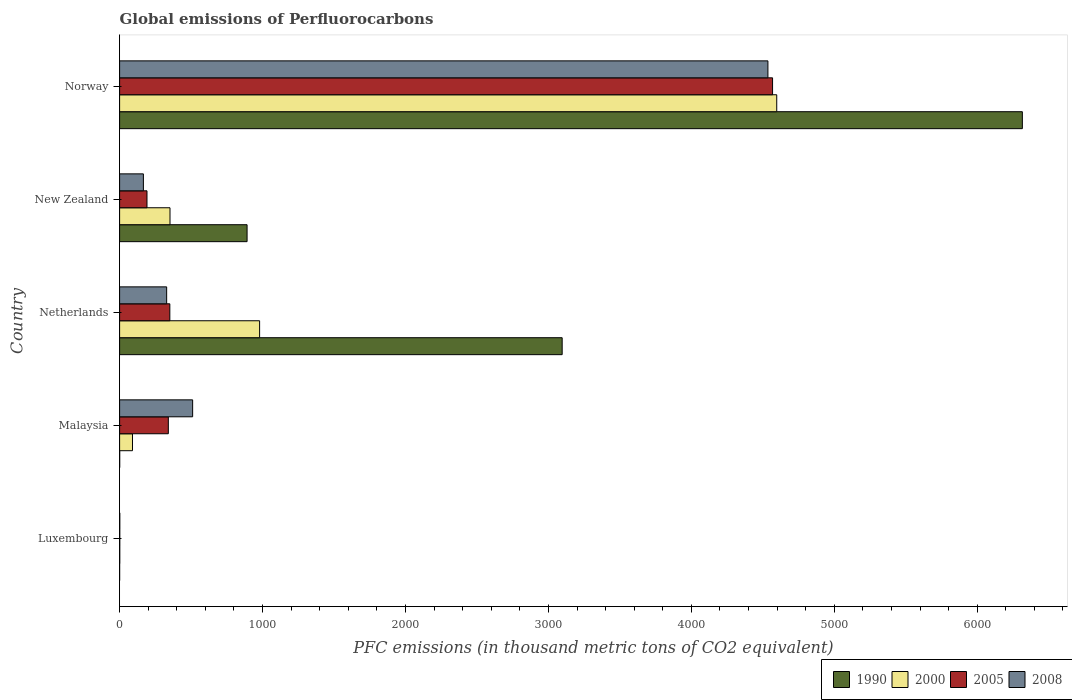Are the number of bars per tick equal to the number of legend labels?
Make the answer very short. Yes. Are the number of bars on each tick of the Y-axis equal?
Your answer should be very brief. Yes. How many bars are there on the 4th tick from the top?
Offer a very short reply. 4. What is the label of the 4th group of bars from the top?
Your answer should be compact. Malaysia. In how many cases, is the number of bars for a given country not equal to the number of legend labels?
Keep it short and to the point. 0. What is the global emissions of Perfluorocarbons in 1990 in Netherlands?
Provide a short and direct response. 3096.2. Across all countries, what is the maximum global emissions of Perfluorocarbons in 2008?
Offer a very short reply. 4535.7. Across all countries, what is the minimum global emissions of Perfluorocarbons in 2005?
Give a very brief answer. 1.1. In which country was the global emissions of Perfluorocarbons in 2008 maximum?
Offer a terse response. Norway. In which country was the global emissions of Perfluorocarbons in 1990 minimum?
Provide a succinct answer. Luxembourg. What is the total global emissions of Perfluorocarbons in 2008 in the graph?
Give a very brief answer. 5543.5. What is the difference between the global emissions of Perfluorocarbons in 2005 in New Zealand and that in Norway?
Keep it short and to the point. -4376.5. What is the difference between the global emissions of Perfluorocarbons in 1990 in Netherlands and the global emissions of Perfluorocarbons in 2008 in New Zealand?
Your answer should be compact. 2929.8. What is the average global emissions of Perfluorocarbons in 2000 per country?
Provide a short and direct response. 1204.1. What is the difference between the global emissions of Perfluorocarbons in 2008 and global emissions of Perfluorocarbons in 1990 in New Zealand?
Your answer should be very brief. -725.4. What is the ratio of the global emissions of Perfluorocarbons in 2008 in Luxembourg to that in Norway?
Provide a succinct answer. 0. Is the global emissions of Perfluorocarbons in 2005 in Luxembourg less than that in Norway?
Your response must be concise. Yes. Is the difference between the global emissions of Perfluorocarbons in 2008 in Malaysia and New Zealand greater than the difference between the global emissions of Perfluorocarbons in 1990 in Malaysia and New Zealand?
Your answer should be compact. Yes. What is the difference between the highest and the second highest global emissions of Perfluorocarbons in 2008?
Your answer should be compact. 4024.7. What is the difference between the highest and the lowest global emissions of Perfluorocarbons in 2008?
Give a very brief answer. 4534.5. Is the sum of the global emissions of Perfluorocarbons in 2000 in New Zealand and Norway greater than the maximum global emissions of Perfluorocarbons in 2008 across all countries?
Your response must be concise. Yes. Is it the case that in every country, the sum of the global emissions of Perfluorocarbons in 2005 and global emissions of Perfluorocarbons in 2008 is greater than the sum of global emissions of Perfluorocarbons in 1990 and global emissions of Perfluorocarbons in 2000?
Your response must be concise. No. What does the 4th bar from the top in Luxembourg represents?
Provide a succinct answer. 1990. What does the 3rd bar from the bottom in Malaysia represents?
Provide a succinct answer. 2005. Is it the case that in every country, the sum of the global emissions of Perfluorocarbons in 1990 and global emissions of Perfluorocarbons in 2005 is greater than the global emissions of Perfluorocarbons in 2000?
Give a very brief answer. Yes. Are all the bars in the graph horizontal?
Your response must be concise. Yes. What is the difference between two consecutive major ticks on the X-axis?
Offer a very short reply. 1000. Does the graph contain any zero values?
Keep it short and to the point. No. Where does the legend appear in the graph?
Provide a short and direct response. Bottom right. How many legend labels are there?
Keep it short and to the point. 4. How are the legend labels stacked?
Keep it short and to the point. Horizontal. What is the title of the graph?
Provide a short and direct response. Global emissions of Perfluorocarbons. What is the label or title of the X-axis?
Give a very brief answer. PFC emissions (in thousand metric tons of CO2 equivalent). What is the PFC emissions (in thousand metric tons of CO2 equivalent) in 1990 in Luxembourg?
Offer a terse response. 0.1. What is the PFC emissions (in thousand metric tons of CO2 equivalent) of 2000 in Luxembourg?
Your answer should be compact. 1. What is the PFC emissions (in thousand metric tons of CO2 equivalent) of 2005 in Luxembourg?
Ensure brevity in your answer.  1.1. What is the PFC emissions (in thousand metric tons of CO2 equivalent) in 2008 in Luxembourg?
Offer a terse response. 1.2. What is the PFC emissions (in thousand metric tons of CO2 equivalent) of 1990 in Malaysia?
Give a very brief answer. 0.6. What is the PFC emissions (in thousand metric tons of CO2 equivalent) of 2000 in Malaysia?
Your answer should be very brief. 90.1. What is the PFC emissions (in thousand metric tons of CO2 equivalent) of 2005 in Malaysia?
Your answer should be very brief. 340.9. What is the PFC emissions (in thousand metric tons of CO2 equivalent) in 2008 in Malaysia?
Make the answer very short. 511. What is the PFC emissions (in thousand metric tons of CO2 equivalent) in 1990 in Netherlands?
Provide a short and direct response. 3096.2. What is the PFC emissions (in thousand metric tons of CO2 equivalent) in 2000 in Netherlands?
Offer a terse response. 979.5. What is the PFC emissions (in thousand metric tons of CO2 equivalent) of 2005 in Netherlands?
Your answer should be compact. 351.4. What is the PFC emissions (in thousand metric tons of CO2 equivalent) of 2008 in Netherlands?
Your answer should be very brief. 329.2. What is the PFC emissions (in thousand metric tons of CO2 equivalent) of 1990 in New Zealand?
Keep it short and to the point. 891.8. What is the PFC emissions (in thousand metric tons of CO2 equivalent) in 2000 in New Zealand?
Make the answer very short. 352.6. What is the PFC emissions (in thousand metric tons of CO2 equivalent) in 2005 in New Zealand?
Your response must be concise. 191.6. What is the PFC emissions (in thousand metric tons of CO2 equivalent) of 2008 in New Zealand?
Ensure brevity in your answer.  166.4. What is the PFC emissions (in thousand metric tons of CO2 equivalent) in 1990 in Norway?
Keep it short and to the point. 6315.7. What is the PFC emissions (in thousand metric tons of CO2 equivalent) in 2000 in Norway?
Ensure brevity in your answer.  4597.3. What is the PFC emissions (in thousand metric tons of CO2 equivalent) of 2005 in Norway?
Make the answer very short. 4568.1. What is the PFC emissions (in thousand metric tons of CO2 equivalent) in 2008 in Norway?
Make the answer very short. 4535.7. Across all countries, what is the maximum PFC emissions (in thousand metric tons of CO2 equivalent) of 1990?
Offer a terse response. 6315.7. Across all countries, what is the maximum PFC emissions (in thousand metric tons of CO2 equivalent) in 2000?
Give a very brief answer. 4597.3. Across all countries, what is the maximum PFC emissions (in thousand metric tons of CO2 equivalent) of 2005?
Provide a short and direct response. 4568.1. Across all countries, what is the maximum PFC emissions (in thousand metric tons of CO2 equivalent) in 2008?
Provide a succinct answer. 4535.7. Across all countries, what is the minimum PFC emissions (in thousand metric tons of CO2 equivalent) of 2005?
Ensure brevity in your answer.  1.1. Across all countries, what is the minimum PFC emissions (in thousand metric tons of CO2 equivalent) in 2008?
Your answer should be very brief. 1.2. What is the total PFC emissions (in thousand metric tons of CO2 equivalent) of 1990 in the graph?
Offer a terse response. 1.03e+04. What is the total PFC emissions (in thousand metric tons of CO2 equivalent) of 2000 in the graph?
Your answer should be compact. 6020.5. What is the total PFC emissions (in thousand metric tons of CO2 equivalent) of 2005 in the graph?
Offer a very short reply. 5453.1. What is the total PFC emissions (in thousand metric tons of CO2 equivalent) of 2008 in the graph?
Offer a terse response. 5543.5. What is the difference between the PFC emissions (in thousand metric tons of CO2 equivalent) in 1990 in Luxembourg and that in Malaysia?
Your answer should be compact. -0.5. What is the difference between the PFC emissions (in thousand metric tons of CO2 equivalent) of 2000 in Luxembourg and that in Malaysia?
Provide a short and direct response. -89.1. What is the difference between the PFC emissions (in thousand metric tons of CO2 equivalent) of 2005 in Luxembourg and that in Malaysia?
Make the answer very short. -339.8. What is the difference between the PFC emissions (in thousand metric tons of CO2 equivalent) of 2008 in Luxembourg and that in Malaysia?
Offer a terse response. -509.8. What is the difference between the PFC emissions (in thousand metric tons of CO2 equivalent) of 1990 in Luxembourg and that in Netherlands?
Make the answer very short. -3096.1. What is the difference between the PFC emissions (in thousand metric tons of CO2 equivalent) of 2000 in Luxembourg and that in Netherlands?
Your answer should be compact. -978.5. What is the difference between the PFC emissions (in thousand metric tons of CO2 equivalent) in 2005 in Luxembourg and that in Netherlands?
Provide a short and direct response. -350.3. What is the difference between the PFC emissions (in thousand metric tons of CO2 equivalent) in 2008 in Luxembourg and that in Netherlands?
Ensure brevity in your answer.  -328. What is the difference between the PFC emissions (in thousand metric tons of CO2 equivalent) in 1990 in Luxembourg and that in New Zealand?
Your answer should be very brief. -891.7. What is the difference between the PFC emissions (in thousand metric tons of CO2 equivalent) of 2000 in Luxembourg and that in New Zealand?
Make the answer very short. -351.6. What is the difference between the PFC emissions (in thousand metric tons of CO2 equivalent) of 2005 in Luxembourg and that in New Zealand?
Your answer should be very brief. -190.5. What is the difference between the PFC emissions (in thousand metric tons of CO2 equivalent) in 2008 in Luxembourg and that in New Zealand?
Ensure brevity in your answer.  -165.2. What is the difference between the PFC emissions (in thousand metric tons of CO2 equivalent) of 1990 in Luxembourg and that in Norway?
Make the answer very short. -6315.6. What is the difference between the PFC emissions (in thousand metric tons of CO2 equivalent) in 2000 in Luxembourg and that in Norway?
Your response must be concise. -4596.3. What is the difference between the PFC emissions (in thousand metric tons of CO2 equivalent) of 2005 in Luxembourg and that in Norway?
Your answer should be very brief. -4567. What is the difference between the PFC emissions (in thousand metric tons of CO2 equivalent) in 2008 in Luxembourg and that in Norway?
Your answer should be very brief. -4534.5. What is the difference between the PFC emissions (in thousand metric tons of CO2 equivalent) in 1990 in Malaysia and that in Netherlands?
Your response must be concise. -3095.6. What is the difference between the PFC emissions (in thousand metric tons of CO2 equivalent) in 2000 in Malaysia and that in Netherlands?
Your answer should be very brief. -889.4. What is the difference between the PFC emissions (in thousand metric tons of CO2 equivalent) of 2008 in Malaysia and that in Netherlands?
Offer a very short reply. 181.8. What is the difference between the PFC emissions (in thousand metric tons of CO2 equivalent) of 1990 in Malaysia and that in New Zealand?
Make the answer very short. -891.2. What is the difference between the PFC emissions (in thousand metric tons of CO2 equivalent) in 2000 in Malaysia and that in New Zealand?
Make the answer very short. -262.5. What is the difference between the PFC emissions (in thousand metric tons of CO2 equivalent) of 2005 in Malaysia and that in New Zealand?
Your answer should be very brief. 149.3. What is the difference between the PFC emissions (in thousand metric tons of CO2 equivalent) in 2008 in Malaysia and that in New Zealand?
Offer a very short reply. 344.6. What is the difference between the PFC emissions (in thousand metric tons of CO2 equivalent) in 1990 in Malaysia and that in Norway?
Provide a short and direct response. -6315.1. What is the difference between the PFC emissions (in thousand metric tons of CO2 equivalent) in 2000 in Malaysia and that in Norway?
Provide a short and direct response. -4507.2. What is the difference between the PFC emissions (in thousand metric tons of CO2 equivalent) in 2005 in Malaysia and that in Norway?
Your answer should be very brief. -4227.2. What is the difference between the PFC emissions (in thousand metric tons of CO2 equivalent) of 2008 in Malaysia and that in Norway?
Keep it short and to the point. -4024.7. What is the difference between the PFC emissions (in thousand metric tons of CO2 equivalent) in 1990 in Netherlands and that in New Zealand?
Provide a short and direct response. 2204.4. What is the difference between the PFC emissions (in thousand metric tons of CO2 equivalent) of 2000 in Netherlands and that in New Zealand?
Ensure brevity in your answer.  626.9. What is the difference between the PFC emissions (in thousand metric tons of CO2 equivalent) in 2005 in Netherlands and that in New Zealand?
Make the answer very short. 159.8. What is the difference between the PFC emissions (in thousand metric tons of CO2 equivalent) in 2008 in Netherlands and that in New Zealand?
Provide a succinct answer. 162.8. What is the difference between the PFC emissions (in thousand metric tons of CO2 equivalent) of 1990 in Netherlands and that in Norway?
Provide a succinct answer. -3219.5. What is the difference between the PFC emissions (in thousand metric tons of CO2 equivalent) in 2000 in Netherlands and that in Norway?
Offer a very short reply. -3617.8. What is the difference between the PFC emissions (in thousand metric tons of CO2 equivalent) in 2005 in Netherlands and that in Norway?
Your answer should be very brief. -4216.7. What is the difference between the PFC emissions (in thousand metric tons of CO2 equivalent) of 2008 in Netherlands and that in Norway?
Make the answer very short. -4206.5. What is the difference between the PFC emissions (in thousand metric tons of CO2 equivalent) of 1990 in New Zealand and that in Norway?
Your answer should be very brief. -5423.9. What is the difference between the PFC emissions (in thousand metric tons of CO2 equivalent) of 2000 in New Zealand and that in Norway?
Your answer should be compact. -4244.7. What is the difference between the PFC emissions (in thousand metric tons of CO2 equivalent) of 2005 in New Zealand and that in Norway?
Provide a succinct answer. -4376.5. What is the difference between the PFC emissions (in thousand metric tons of CO2 equivalent) in 2008 in New Zealand and that in Norway?
Make the answer very short. -4369.3. What is the difference between the PFC emissions (in thousand metric tons of CO2 equivalent) of 1990 in Luxembourg and the PFC emissions (in thousand metric tons of CO2 equivalent) of 2000 in Malaysia?
Offer a very short reply. -90. What is the difference between the PFC emissions (in thousand metric tons of CO2 equivalent) of 1990 in Luxembourg and the PFC emissions (in thousand metric tons of CO2 equivalent) of 2005 in Malaysia?
Offer a very short reply. -340.8. What is the difference between the PFC emissions (in thousand metric tons of CO2 equivalent) of 1990 in Luxembourg and the PFC emissions (in thousand metric tons of CO2 equivalent) of 2008 in Malaysia?
Your answer should be compact. -510.9. What is the difference between the PFC emissions (in thousand metric tons of CO2 equivalent) of 2000 in Luxembourg and the PFC emissions (in thousand metric tons of CO2 equivalent) of 2005 in Malaysia?
Your response must be concise. -339.9. What is the difference between the PFC emissions (in thousand metric tons of CO2 equivalent) in 2000 in Luxembourg and the PFC emissions (in thousand metric tons of CO2 equivalent) in 2008 in Malaysia?
Offer a very short reply. -510. What is the difference between the PFC emissions (in thousand metric tons of CO2 equivalent) in 2005 in Luxembourg and the PFC emissions (in thousand metric tons of CO2 equivalent) in 2008 in Malaysia?
Offer a terse response. -509.9. What is the difference between the PFC emissions (in thousand metric tons of CO2 equivalent) in 1990 in Luxembourg and the PFC emissions (in thousand metric tons of CO2 equivalent) in 2000 in Netherlands?
Your response must be concise. -979.4. What is the difference between the PFC emissions (in thousand metric tons of CO2 equivalent) in 1990 in Luxembourg and the PFC emissions (in thousand metric tons of CO2 equivalent) in 2005 in Netherlands?
Make the answer very short. -351.3. What is the difference between the PFC emissions (in thousand metric tons of CO2 equivalent) in 1990 in Luxembourg and the PFC emissions (in thousand metric tons of CO2 equivalent) in 2008 in Netherlands?
Give a very brief answer. -329.1. What is the difference between the PFC emissions (in thousand metric tons of CO2 equivalent) of 2000 in Luxembourg and the PFC emissions (in thousand metric tons of CO2 equivalent) of 2005 in Netherlands?
Your answer should be compact. -350.4. What is the difference between the PFC emissions (in thousand metric tons of CO2 equivalent) in 2000 in Luxembourg and the PFC emissions (in thousand metric tons of CO2 equivalent) in 2008 in Netherlands?
Make the answer very short. -328.2. What is the difference between the PFC emissions (in thousand metric tons of CO2 equivalent) in 2005 in Luxembourg and the PFC emissions (in thousand metric tons of CO2 equivalent) in 2008 in Netherlands?
Your answer should be very brief. -328.1. What is the difference between the PFC emissions (in thousand metric tons of CO2 equivalent) in 1990 in Luxembourg and the PFC emissions (in thousand metric tons of CO2 equivalent) in 2000 in New Zealand?
Keep it short and to the point. -352.5. What is the difference between the PFC emissions (in thousand metric tons of CO2 equivalent) in 1990 in Luxembourg and the PFC emissions (in thousand metric tons of CO2 equivalent) in 2005 in New Zealand?
Your response must be concise. -191.5. What is the difference between the PFC emissions (in thousand metric tons of CO2 equivalent) of 1990 in Luxembourg and the PFC emissions (in thousand metric tons of CO2 equivalent) of 2008 in New Zealand?
Provide a short and direct response. -166.3. What is the difference between the PFC emissions (in thousand metric tons of CO2 equivalent) of 2000 in Luxembourg and the PFC emissions (in thousand metric tons of CO2 equivalent) of 2005 in New Zealand?
Give a very brief answer. -190.6. What is the difference between the PFC emissions (in thousand metric tons of CO2 equivalent) in 2000 in Luxembourg and the PFC emissions (in thousand metric tons of CO2 equivalent) in 2008 in New Zealand?
Ensure brevity in your answer.  -165.4. What is the difference between the PFC emissions (in thousand metric tons of CO2 equivalent) in 2005 in Luxembourg and the PFC emissions (in thousand metric tons of CO2 equivalent) in 2008 in New Zealand?
Provide a succinct answer. -165.3. What is the difference between the PFC emissions (in thousand metric tons of CO2 equivalent) of 1990 in Luxembourg and the PFC emissions (in thousand metric tons of CO2 equivalent) of 2000 in Norway?
Give a very brief answer. -4597.2. What is the difference between the PFC emissions (in thousand metric tons of CO2 equivalent) in 1990 in Luxembourg and the PFC emissions (in thousand metric tons of CO2 equivalent) in 2005 in Norway?
Ensure brevity in your answer.  -4568. What is the difference between the PFC emissions (in thousand metric tons of CO2 equivalent) of 1990 in Luxembourg and the PFC emissions (in thousand metric tons of CO2 equivalent) of 2008 in Norway?
Your answer should be compact. -4535.6. What is the difference between the PFC emissions (in thousand metric tons of CO2 equivalent) of 2000 in Luxembourg and the PFC emissions (in thousand metric tons of CO2 equivalent) of 2005 in Norway?
Your answer should be compact. -4567.1. What is the difference between the PFC emissions (in thousand metric tons of CO2 equivalent) of 2000 in Luxembourg and the PFC emissions (in thousand metric tons of CO2 equivalent) of 2008 in Norway?
Make the answer very short. -4534.7. What is the difference between the PFC emissions (in thousand metric tons of CO2 equivalent) of 2005 in Luxembourg and the PFC emissions (in thousand metric tons of CO2 equivalent) of 2008 in Norway?
Your response must be concise. -4534.6. What is the difference between the PFC emissions (in thousand metric tons of CO2 equivalent) of 1990 in Malaysia and the PFC emissions (in thousand metric tons of CO2 equivalent) of 2000 in Netherlands?
Ensure brevity in your answer.  -978.9. What is the difference between the PFC emissions (in thousand metric tons of CO2 equivalent) in 1990 in Malaysia and the PFC emissions (in thousand metric tons of CO2 equivalent) in 2005 in Netherlands?
Your answer should be very brief. -350.8. What is the difference between the PFC emissions (in thousand metric tons of CO2 equivalent) of 1990 in Malaysia and the PFC emissions (in thousand metric tons of CO2 equivalent) of 2008 in Netherlands?
Provide a succinct answer. -328.6. What is the difference between the PFC emissions (in thousand metric tons of CO2 equivalent) in 2000 in Malaysia and the PFC emissions (in thousand metric tons of CO2 equivalent) in 2005 in Netherlands?
Keep it short and to the point. -261.3. What is the difference between the PFC emissions (in thousand metric tons of CO2 equivalent) in 2000 in Malaysia and the PFC emissions (in thousand metric tons of CO2 equivalent) in 2008 in Netherlands?
Your answer should be compact. -239.1. What is the difference between the PFC emissions (in thousand metric tons of CO2 equivalent) of 1990 in Malaysia and the PFC emissions (in thousand metric tons of CO2 equivalent) of 2000 in New Zealand?
Your answer should be compact. -352. What is the difference between the PFC emissions (in thousand metric tons of CO2 equivalent) of 1990 in Malaysia and the PFC emissions (in thousand metric tons of CO2 equivalent) of 2005 in New Zealand?
Offer a very short reply. -191. What is the difference between the PFC emissions (in thousand metric tons of CO2 equivalent) of 1990 in Malaysia and the PFC emissions (in thousand metric tons of CO2 equivalent) of 2008 in New Zealand?
Provide a short and direct response. -165.8. What is the difference between the PFC emissions (in thousand metric tons of CO2 equivalent) of 2000 in Malaysia and the PFC emissions (in thousand metric tons of CO2 equivalent) of 2005 in New Zealand?
Ensure brevity in your answer.  -101.5. What is the difference between the PFC emissions (in thousand metric tons of CO2 equivalent) of 2000 in Malaysia and the PFC emissions (in thousand metric tons of CO2 equivalent) of 2008 in New Zealand?
Provide a succinct answer. -76.3. What is the difference between the PFC emissions (in thousand metric tons of CO2 equivalent) in 2005 in Malaysia and the PFC emissions (in thousand metric tons of CO2 equivalent) in 2008 in New Zealand?
Offer a terse response. 174.5. What is the difference between the PFC emissions (in thousand metric tons of CO2 equivalent) of 1990 in Malaysia and the PFC emissions (in thousand metric tons of CO2 equivalent) of 2000 in Norway?
Offer a very short reply. -4596.7. What is the difference between the PFC emissions (in thousand metric tons of CO2 equivalent) of 1990 in Malaysia and the PFC emissions (in thousand metric tons of CO2 equivalent) of 2005 in Norway?
Provide a succinct answer. -4567.5. What is the difference between the PFC emissions (in thousand metric tons of CO2 equivalent) in 1990 in Malaysia and the PFC emissions (in thousand metric tons of CO2 equivalent) in 2008 in Norway?
Offer a terse response. -4535.1. What is the difference between the PFC emissions (in thousand metric tons of CO2 equivalent) of 2000 in Malaysia and the PFC emissions (in thousand metric tons of CO2 equivalent) of 2005 in Norway?
Provide a succinct answer. -4478. What is the difference between the PFC emissions (in thousand metric tons of CO2 equivalent) in 2000 in Malaysia and the PFC emissions (in thousand metric tons of CO2 equivalent) in 2008 in Norway?
Give a very brief answer. -4445.6. What is the difference between the PFC emissions (in thousand metric tons of CO2 equivalent) of 2005 in Malaysia and the PFC emissions (in thousand metric tons of CO2 equivalent) of 2008 in Norway?
Keep it short and to the point. -4194.8. What is the difference between the PFC emissions (in thousand metric tons of CO2 equivalent) of 1990 in Netherlands and the PFC emissions (in thousand metric tons of CO2 equivalent) of 2000 in New Zealand?
Provide a succinct answer. 2743.6. What is the difference between the PFC emissions (in thousand metric tons of CO2 equivalent) in 1990 in Netherlands and the PFC emissions (in thousand metric tons of CO2 equivalent) in 2005 in New Zealand?
Your answer should be very brief. 2904.6. What is the difference between the PFC emissions (in thousand metric tons of CO2 equivalent) of 1990 in Netherlands and the PFC emissions (in thousand metric tons of CO2 equivalent) of 2008 in New Zealand?
Offer a terse response. 2929.8. What is the difference between the PFC emissions (in thousand metric tons of CO2 equivalent) in 2000 in Netherlands and the PFC emissions (in thousand metric tons of CO2 equivalent) in 2005 in New Zealand?
Ensure brevity in your answer.  787.9. What is the difference between the PFC emissions (in thousand metric tons of CO2 equivalent) of 2000 in Netherlands and the PFC emissions (in thousand metric tons of CO2 equivalent) of 2008 in New Zealand?
Ensure brevity in your answer.  813.1. What is the difference between the PFC emissions (in thousand metric tons of CO2 equivalent) of 2005 in Netherlands and the PFC emissions (in thousand metric tons of CO2 equivalent) of 2008 in New Zealand?
Your response must be concise. 185. What is the difference between the PFC emissions (in thousand metric tons of CO2 equivalent) in 1990 in Netherlands and the PFC emissions (in thousand metric tons of CO2 equivalent) in 2000 in Norway?
Your answer should be compact. -1501.1. What is the difference between the PFC emissions (in thousand metric tons of CO2 equivalent) of 1990 in Netherlands and the PFC emissions (in thousand metric tons of CO2 equivalent) of 2005 in Norway?
Your response must be concise. -1471.9. What is the difference between the PFC emissions (in thousand metric tons of CO2 equivalent) of 1990 in Netherlands and the PFC emissions (in thousand metric tons of CO2 equivalent) of 2008 in Norway?
Offer a terse response. -1439.5. What is the difference between the PFC emissions (in thousand metric tons of CO2 equivalent) of 2000 in Netherlands and the PFC emissions (in thousand metric tons of CO2 equivalent) of 2005 in Norway?
Provide a short and direct response. -3588.6. What is the difference between the PFC emissions (in thousand metric tons of CO2 equivalent) in 2000 in Netherlands and the PFC emissions (in thousand metric tons of CO2 equivalent) in 2008 in Norway?
Give a very brief answer. -3556.2. What is the difference between the PFC emissions (in thousand metric tons of CO2 equivalent) of 2005 in Netherlands and the PFC emissions (in thousand metric tons of CO2 equivalent) of 2008 in Norway?
Your answer should be compact. -4184.3. What is the difference between the PFC emissions (in thousand metric tons of CO2 equivalent) in 1990 in New Zealand and the PFC emissions (in thousand metric tons of CO2 equivalent) in 2000 in Norway?
Your answer should be compact. -3705.5. What is the difference between the PFC emissions (in thousand metric tons of CO2 equivalent) in 1990 in New Zealand and the PFC emissions (in thousand metric tons of CO2 equivalent) in 2005 in Norway?
Provide a succinct answer. -3676.3. What is the difference between the PFC emissions (in thousand metric tons of CO2 equivalent) of 1990 in New Zealand and the PFC emissions (in thousand metric tons of CO2 equivalent) of 2008 in Norway?
Offer a terse response. -3643.9. What is the difference between the PFC emissions (in thousand metric tons of CO2 equivalent) of 2000 in New Zealand and the PFC emissions (in thousand metric tons of CO2 equivalent) of 2005 in Norway?
Give a very brief answer. -4215.5. What is the difference between the PFC emissions (in thousand metric tons of CO2 equivalent) in 2000 in New Zealand and the PFC emissions (in thousand metric tons of CO2 equivalent) in 2008 in Norway?
Your answer should be very brief. -4183.1. What is the difference between the PFC emissions (in thousand metric tons of CO2 equivalent) in 2005 in New Zealand and the PFC emissions (in thousand metric tons of CO2 equivalent) in 2008 in Norway?
Make the answer very short. -4344.1. What is the average PFC emissions (in thousand metric tons of CO2 equivalent) of 1990 per country?
Keep it short and to the point. 2060.88. What is the average PFC emissions (in thousand metric tons of CO2 equivalent) of 2000 per country?
Offer a terse response. 1204.1. What is the average PFC emissions (in thousand metric tons of CO2 equivalent) of 2005 per country?
Your response must be concise. 1090.62. What is the average PFC emissions (in thousand metric tons of CO2 equivalent) in 2008 per country?
Give a very brief answer. 1108.7. What is the difference between the PFC emissions (in thousand metric tons of CO2 equivalent) of 1990 and PFC emissions (in thousand metric tons of CO2 equivalent) of 2000 in Malaysia?
Your response must be concise. -89.5. What is the difference between the PFC emissions (in thousand metric tons of CO2 equivalent) in 1990 and PFC emissions (in thousand metric tons of CO2 equivalent) in 2005 in Malaysia?
Ensure brevity in your answer.  -340.3. What is the difference between the PFC emissions (in thousand metric tons of CO2 equivalent) of 1990 and PFC emissions (in thousand metric tons of CO2 equivalent) of 2008 in Malaysia?
Provide a succinct answer. -510.4. What is the difference between the PFC emissions (in thousand metric tons of CO2 equivalent) of 2000 and PFC emissions (in thousand metric tons of CO2 equivalent) of 2005 in Malaysia?
Offer a very short reply. -250.8. What is the difference between the PFC emissions (in thousand metric tons of CO2 equivalent) in 2000 and PFC emissions (in thousand metric tons of CO2 equivalent) in 2008 in Malaysia?
Your answer should be compact. -420.9. What is the difference between the PFC emissions (in thousand metric tons of CO2 equivalent) of 2005 and PFC emissions (in thousand metric tons of CO2 equivalent) of 2008 in Malaysia?
Offer a very short reply. -170.1. What is the difference between the PFC emissions (in thousand metric tons of CO2 equivalent) of 1990 and PFC emissions (in thousand metric tons of CO2 equivalent) of 2000 in Netherlands?
Ensure brevity in your answer.  2116.7. What is the difference between the PFC emissions (in thousand metric tons of CO2 equivalent) in 1990 and PFC emissions (in thousand metric tons of CO2 equivalent) in 2005 in Netherlands?
Keep it short and to the point. 2744.8. What is the difference between the PFC emissions (in thousand metric tons of CO2 equivalent) of 1990 and PFC emissions (in thousand metric tons of CO2 equivalent) of 2008 in Netherlands?
Ensure brevity in your answer.  2767. What is the difference between the PFC emissions (in thousand metric tons of CO2 equivalent) in 2000 and PFC emissions (in thousand metric tons of CO2 equivalent) in 2005 in Netherlands?
Give a very brief answer. 628.1. What is the difference between the PFC emissions (in thousand metric tons of CO2 equivalent) in 2000 and PFC emissions (in thousand metric tons of CO2 equivalent) in 2008 in Netherlands?
Keep it short and to the point. 650.3. What is the difference between the PFC emissions (in thousand metric tons of CO2 equivalent) of 1990 and PFC emissions (in thousand metric tons of CO2 equivalent) of 2000 in New Zealand?
Provide a succinct answer. 539.2. What is the difference between the PFC emissions (in thousand metric tons of CO2 equivalent) in 1990 and PFC emissions (in thousand metric tons of CO2 equivalent) in 2005 in New Zealand?
Ensure brevity in your answer.  700.2. What is the difference between the PFC emissions (in thousand metric tons of CO2 equivalent) in 1990 and PFC emissions (in thousand metric tons of CO2 equivalent) in 2008 in New Zealand?
Your answer should be very brief. 725.4. What is the difference between the PFC emissions (in thousand metric tons of CO2 equivalent) in 2000 and PFC emissions (in thousand metric tons of CO2 equivalent) in 2005 in New Zealand?
Give a very brief answer. 161. What is the difference between the PFC emissions (in thousand metric tons of CO2 equivalent) in 2000 and PFC emissions (in thousand metric tons of CO2 equivalent) in 2008 in New Zealand?
Ensure brevity in your answer.  186.2. What is the difference between the PFC emissions (in thousand metric tons of CO2 equivalent) in 2005 and PFC emissions (in thousand metric tons of CO2 equivalent) in 2008 in New Zealand?
Keep it short and to the point. 25.2. What is the difference between the PFC emissions (in thousand metric tons of CO2 equivalent) in 1990 and PFC emissions (in thousand metric tons of CO2 equivalent) in 2000 in Norway?
Make the answer very short. 1718.4. What is the difference between the PFC emissions (in thousand metric tons of CO2 equivalent) of 1990 and PFC emissions (in thousand metric tons of CO2 equivalent) of 2005 in Norway?
Your answer should be compact. 1747.6. What is the difference between the PFC emissions (in thousand metric tons of CO2 equivalent) of 1990 and PFC emissions (in thousand metric tons of CO2 equivalent) of 2008 in Norway?
Give a very brief answer. 1780. What is the difference between the PFC emissions (in thousand metric tons of CO2 equivalent) of 2000 and PFC emissions (in thousand metric tons of CO2 equivalent) of 2005 in Norway?
Your answer should be compact. 29.2. What is the difference between the PFC emissions (in thousand metric tons of CO2 equivalent) of 2000 and PFC emissions (in thousand metric tons of CO2 equivalent) of 2008 in Norway?
Give a very brief answer. 61.6. What is the difference between the PFC emissions (in thousand metric tons of CO2 equivalent) of 2005 and PFC emissions (in thousand metric tons of CO2 equivalent) of 2008 in Norway?
Offer a very short reply. 32.4. What is the ratio of the PFC emissions (in thousand metric tons of CO2 equivalent) of 1990 in Luxembourg to that in Malaysia?
Your answer should be compact. 0.17. What is the ratio of the PFC emissions (in thousand metric tons of CO2 equivalent) of 2000 in Luxembourg to that in Malaysia?
Provide a succinct answer. 0.01. What is the ratio of the PFC emissions (in thousand metric tons of CO2 equivalent) in 2005 in Luxembourg to that in Malaysia?
Offer a terse response. 0. What is the ratio of the PFC emissions (in thousand metric tons of CO2 equivalent) in 2008 in Luxembourg to that in Malaysia?
Provide a succinct answer. 0. What is the ratio of the PFC emissions (in thousand metric tons of CO2 equivalent) of 2000 in Luxembourg to that in Netherlands?
Make the answer very short. 0. What is the ratio of the PFC emissions (in thousand metric tons of CO2 equivalent) of 2005 in Luxembourg to that in Netherlands?
Make the answer very short. 0. What is the ratio of the PFC emissions (in thousand metric tons of CO2 equivalent) of 2008 in Luxembourg to that in Netherlands?
Your answer should be very brief. 0. What is the ratio of the PFC emissions (in thousand metric tons of CO2 equivalent) in 1990 in Luxembourg to that in New Zealand?
Your answer should be very brief. 0. What is the ratio of the PFC emissions (in thousand metric tons of CO2 equivalent) in 2000 in Luxembourg to that in New Zealand?
Provide a short and direct response. 0. What is the ratio of the PFC emissions (in thousand metric tons of CO2 equivalent) of 2005 in Luxembourg to that in New Zealand?
Give a very brief answer. 0.01. What is the ratio of the PFC emissions (in thousand metric tons of CO2 equivalent) of 2008 in Luxembourg to that in New Zealand?
Offer a very short reply. 0.01. What is the ratio of the PFC emissions (in thousand metric tons of CO2 equivalent) in 1990 in Luxembourg to that in Norway?
Keep it short and to the point. 0. What is the ratio of the PFC emissions (in thousand metric tons of CO2 equivalent) of 1990 in Malaysia to that in Netherlands?
Provide a short and direct response. 0. What is the ratio of the PFC emissions (in thousand metric tons of CO2 equivalent) in 2000 in Malaysia to that in Netherlands?
Provide a short and direct response. 0.09. What is the ratio of the PFC emissions (in thousand metric tons of CO2 equivalent) in 2005 in Malaysia to that in Netherlands?
Your answer should be compact. 0.97. What is the ratio of the PFC emissions (in thousand metric tons of CO2 equivalent) of 2008 in Malaysia to that in Netherlands?
Ensure brevity in your answer.  1.55. What is the ratio of the PFC emissions (in thousand metric tons of CO2 equivalent) in 1990 in Malaysia to that in New Zealand?
Your answer should be compact. 0. What is the ratio of the PFC emissions (in thousand metric tons of CO2 equivalent) of 2000 in Malaysia to that in New Zealand?
Give a very brief answer. 0.26. What is the ratio of the PFC emissions (in thousand metric tons of CO2 equivalent) of 2005 in Malaysia to that in New Zealand?
Keep it short and to the point. 1.78. What is the ratio of the PFC emissions (in thousand metric tons of CO2 equivalent) of 2008 in Malaysia to that in New Zealand?
Ensure brevity in your answer.  3.07. What is the ratio of the PFC emissions (in thousand metric tons of CO2 equivalent) of 1990 in Malaysia to that in Norway?
Offer a terse response. 0. What is the ratio of the PFC emissions (in thousand metric tons of CO2 equivalent) of 2000 in Malaysia to that in Norway?
Your answer should be compact. 0.02. What is the ratio of the PFC emissions (in thousand metric tons of CO2 equivalent) of 2005 in Malaysia to that in Norway?
Offer a terse response. 0.07. What is the ratio of the PFC emissions (in thousand metric tons of CO2 equivalent) of 2008 in Malaysia to that in Norway?
Provide a short and direct response. 0.11. What is the ratio of the PFC emissions (in thousand metric tons of CO2 equivalent) in 1990 in Netherlands to that in New Zealand?
Ensure brevity in your answer.  3.47. What is the ratio of the PFC emissions (in thousand metric tons of CO2 equivalent) in 2000 in Netherlands to that in New Zealand?
Your answer should be very brief. 2.78. What is the ratio of the PFC emissions (in thousand metric tons of CO2 equivalent) of 2005 in Netherlands to that in New Zealand?
Give a very brief answer. 1.83. What is the ratio of the PFC emissions (in thousand metric tons of CO2 equivalent) of 2008 in Netherlands to that in New Zealand?
Offer a terse response. 1.98. What is the ratio of the PFC emissions (in thousand metric tons of CO2 equivalent) of 1990 in Netherlands to that in Norway?
Ensure brevity in your answer.  0.49. What is the ratio of the PFC emissions (in thousand metric tons of CO2 equivalent) of 2000 in Netherlands to that in Norway?
Your answer should be compact. 0.21. What is the ratio of the PFC emissions (in thousand metric tons of CO2 equivalent) in 2005 in Netherlands to that in Norway?
Ensure brevity in your answer.  0.08. What is the ratio of the PFC emissions (in thousand metric tons of CO2 equivalent) in 2008 in Netherlands to that in Norway?
Offer a terse response. 0.07. What is the ratio of the PFC emissions (in thousand metric tons of CO2 equivalent) in 1990 in New Zealand to that in Norway?
Keep it short and to the point. 0.14. What is the ratio of the PFC emissions (in thousand metric tons of CO2 equivalent) of 2000 in New Zealand to that in Norway?
Give a very brief answer. 0.08. What is the ratio of the PFC emissions (in thousand metric tons of CO2 equivalent) of 2005 in New Zealand to that in Norway?
Your response must be concise. 0.04. What is the ratio of the PFC emissions (in thousand metric tons of CO2 equivalent) of 2008 in New Zealand to that in Norway?
Provide a succinct answer. 0.04. What is the difference between the highest and the second highest PFC emissions (in thousand metric tons of CO2 equivalent) in 1990?
Ensure brevity in your answer.  3219.5. What is the difference between the highest and the second highest PFC emissions (in thousand metric tons of CO2 equivalent) of 2000?
Provide a short and direct response. 3617.8. What is the difference between the highest and the second highest PFC emissions (in thousand metric tons of CO2 equivalent) in 2005?
Make the answer very short. 4216.7. What is the difference between the highest and the second highest PFC emissions (in thousand metric tons of CO2 equivalent) of 2008?
Your answer should be very brief. 4024.7. What is the difference between the highest and the lowest PFC emissions (in thousand metric tons of CO2 equivalent) in 1990?
Provide a succinct answer. 6315.6. What is the difference between the highest and the lowest PFC emissions (in thousand metric tons of CO2 equivalent) of 2000?
Your answer should be very brief. 4596.3. What is the difference between the highest and the lowest PFC emissions (in thousand metric tons of CO2 equivalent) of 2005?
Ensure brevity in your answer.  4567. What is the difference between the highest and the lowest PFC emissions (in thousand metric tons of CO2 equivalent) in 2008?
Provide a succinct answer. 4534.5. 